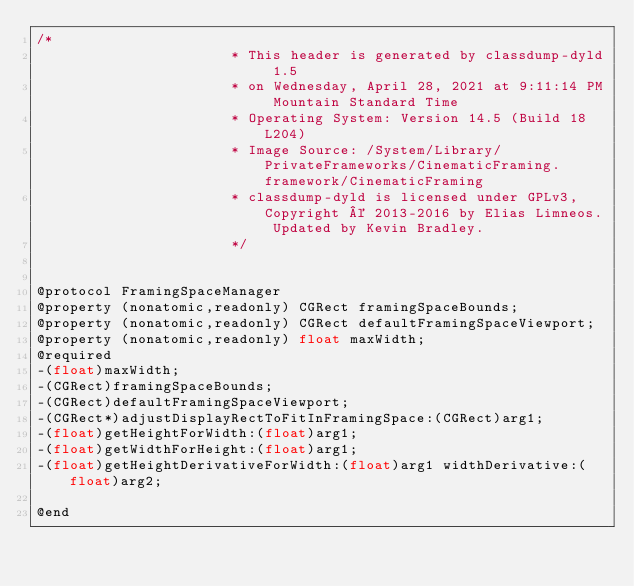Convert code to text. <code><loc_0><loc_0><loc_500><loc_500><_C_>/*
                       * This header is generated by classdump-dyld 1.5
                       * on Wednesday, April 28, 2021 at 9:11:14 PM Mountain Standard Time
                       * Operating System: Version 14.5 (Build 18L204)
                       * Image Source: /System/Library/PrivateFrameworks/CinematicFraming.framework/CinematicFraming
                       * classdump-dyld is licensed under GPLv3, Copyright © 2013-2016 by Elias Limneos. Updated by Kevin Bradley.
                       */


@protocol FramingSpaceManager
@property (nonatomic,readonly) CGRect framingSpaceBounds; 
@property (nonatomic,readonly) CGRect defaultFramingSpaceViewport; 
@property (nonatomic,readonly) float maxWidth; 
@required
-(float)maxWidth;
-(CGRect)framingSpaceBounds;
-(CGRect)defaultFramingSpaceViewport;
-(CGRect*)adjustDisplayRectToFitInFramingSpace:(CGRect)arg1;
-(float)getHeightForWidth:(float)arg1;
-(float)getWidthForHeight:(float)arg1;
-(float)getHeightDerivativeForWidth:(float)arg1 widthDerivative:(float)arg2;

@end

</code> 